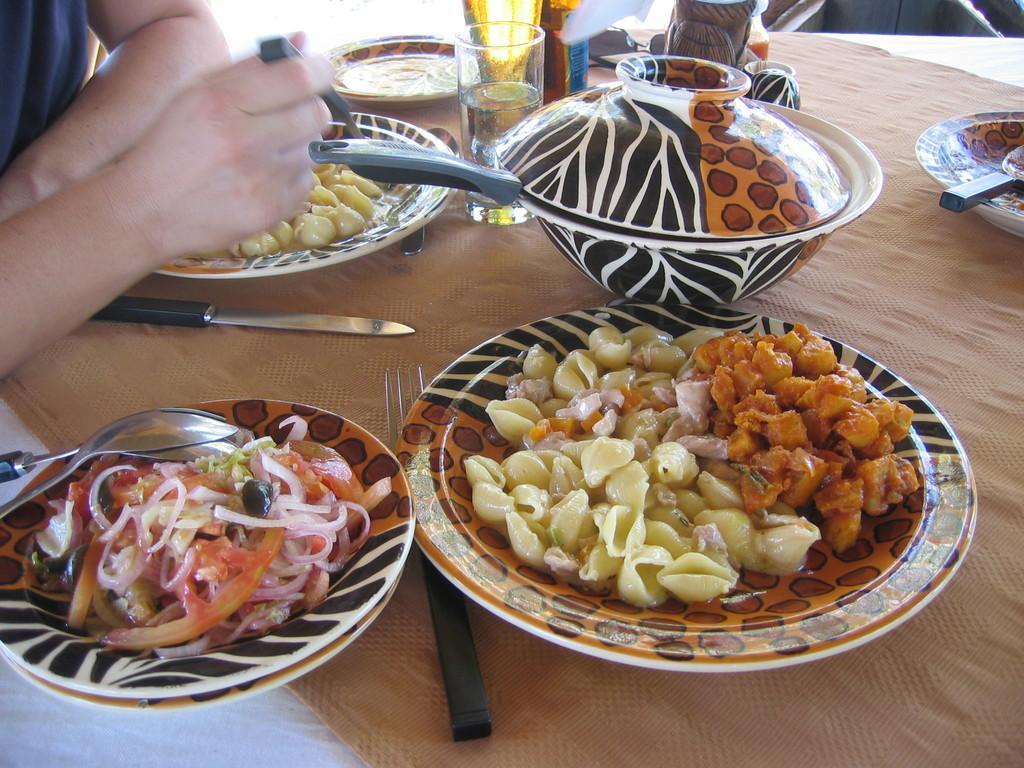Could you give a brief overview of what you see in this image? In this picture we can see plates with food items on it, fork, knife, spoon, bowl, glasses and these all are placed on the table and beside this table we can see a person. 